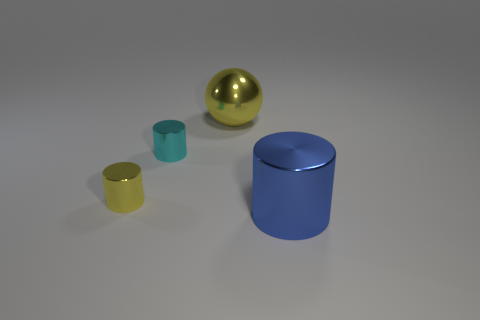How many yellow objects are in front of the large thing left of the big blue cylinder?
Provide a short and direct response. 1. What shape is the large metallic thing that is behind the big thing in front of the large thing that is left of the blue cylinder?
Keep it short and to the point. Sphere. There is a metal thing that is the same color as the large ball; what size is it?
Provide a short and direct response. Small. What number of things are cyan metallic things or cyan rubber cubes?
Provide a short and direct response. 1. What color is the thing that is the same size as the blue metal cylinder?
Offer a very short reply. Yellow. Do the big yellow object and the yellow metallic thing in front of the cyan thing have the same shape?
Give a very brief answer. No. How many objects are metal things behind the big blue cylinder or metal cylinders that are behind the small yellow cylinder?
Your answer should be very brief. 3. What is the shape of the metallic object that is the same color as the shiny ball?
Keep it short and to the point. Cylinder. What is the shape of the thing behind the cyan metal thing?
Ensure brevity in your answer.  Sphere. Do the small thing in front of the small cyan metal object and the blue metallic thing have the same shape?
Give a very brief answer. Yes. 